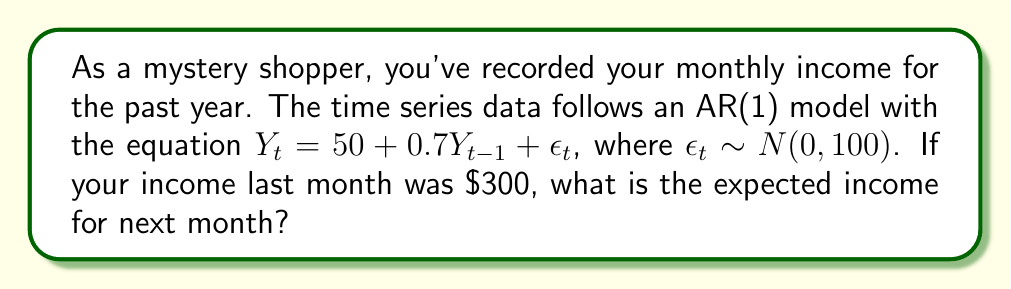Teach me how to tackle this problem. To solve this problem, we'll follow these steps:

1) Recall the AR(1) model equation:
   $Y_t = 50 + 0.7Y_{t-1} + \epsilon_t$

2) We're asked to find the expected income for next month. In time series notation, this is $E[Y_{t+1}|Y_t]$.

3) To calculate this, we use the properties of conditional expectation:
   $E[Y_{t+1}|Y_t] = E[50 + 0.7Y_t + \epsilon_{t+1}|Y_t]$

4) We can simplify this:
   $E[Y_{t+1}|Y_t] = E[50|Y_t] + E[0.7Y_t|Y_t] + E[\epsilon_{t+1}|Y_t]$

5) Simplify further:
   - $E[50|Y_t] = 50$ (constant)
   - $E[0.7Y_t|Y_t] = 0.7Y_t$ (given $Y_t$)
   - $E[\epsilon_{t+1}|Y_t] = 0$ (white noise has mean zero)

6) Therefore:
   $E[Y_{t+1}|Y_t] = 50 + 0.7Y_t$

7) We're given that last month's income ($Y_t$) was $300. Let's substitute this:
   $E[Y_{t+1}|Y_t = 300] = 50 + 0.7(300) = 50 + 210 = 260$

Thus, the expected income for next month is $260.
Answer: $260 